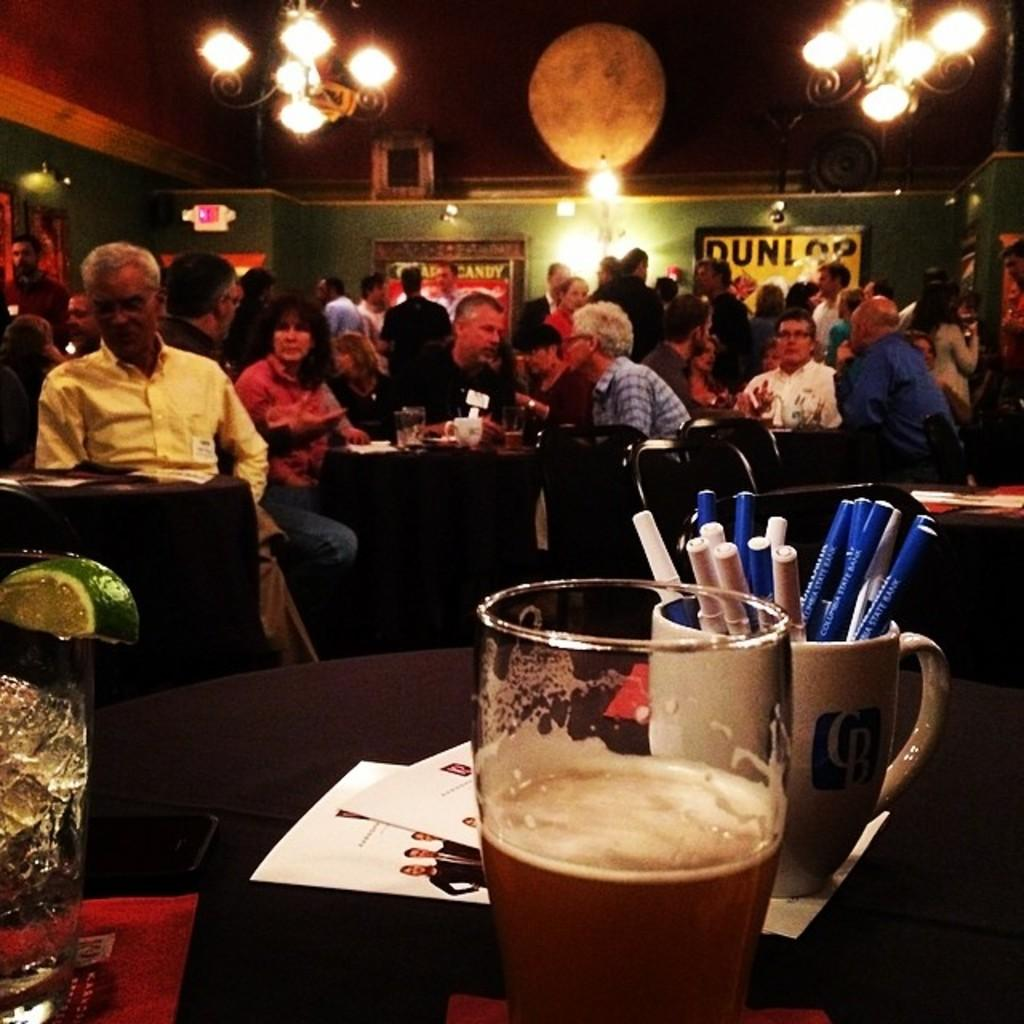Provide a one-sentence caption for the provided image. A bar with a dunlop poster on the wall is crowded with people. 